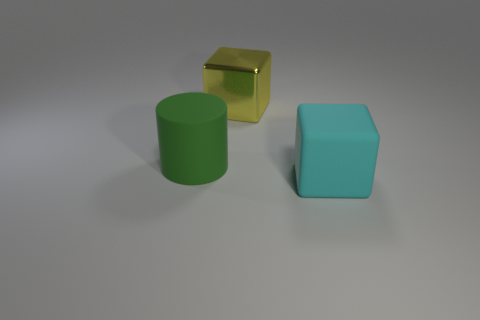Add 1 large gray cubes. How many objects exist? 4 Subtract all cyan cubes. How many cubes are left? 1 Subtract all cubes. How many objects are left? 1 Subtract all gray cylinders. How many yellow cubes are left? 1 Add 3 big cyan things. How many big cyan things are left? 4 Add 3 cylinders. How many cylinders exist? 4 Subtract 0 blue spheres. How many objects are left? 3 Subtract all brown blocks. Subtract all gray cylinders. How many blocks are left? 2 Subtract all large yellow metallic blocks. Subtract all large green matte balls. How many objects are left? 2 